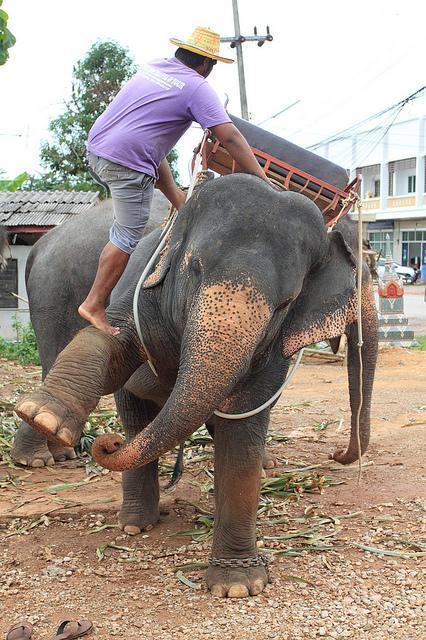How many elephants are in this picture?
Give a very brief answer. 1. How many people are riding?
Give a very brief answer. 1. 